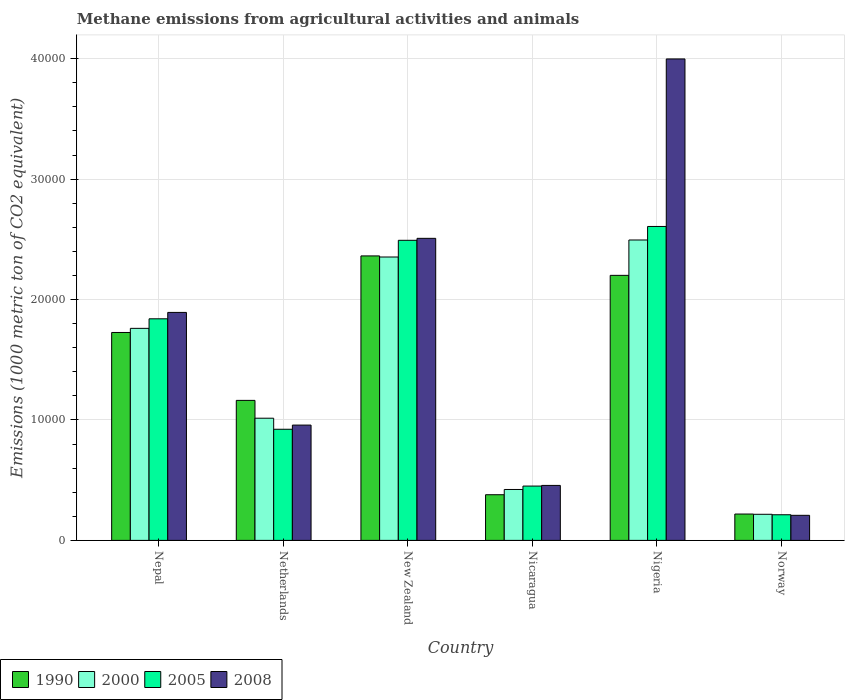How many different coloured bars are there?
Give a very brief answer. 4. Are the number of bars on each tick of the X-axis equal?
Keep it short and to the point. Yes. How many bars are there on the 2nd tick from the right?
Offer a terse response. 4. What is the label of the 5th group of bars from the left?
Your answer should be very brief. Nigeria. In how many cases, is the number of bars for a given country not equal to the number of legend labels?
Ensure brevity in your answer.  0. What is the amount of methane emitted in 2000 in Nigeria?
Your response must be concise. 2.49e+04. Across all countries, what is the maximum amount of methane emitted in 2000?
Provide a succinct answer. 2.49e+04. Across all countries, what is the minimum amount of methane emitted in 2008?
Your response must be concise. 2081.3. In which country was the amount of methane emitted in 2008 maximum?
Provide a short and direct response. Nigeria. What is the total amount of methane emitted in 2005 in the graph?
Your response must be concise. 8.53e+04. What is the difference between the amount of methane emitted in 1990 in Nepal and that in Norway?
Ensure brevity in your answer.  1.51e+04. What is the difference between the amount of methane emitted in 2000 in Nicaragua and the amount of methane emitted in 1990 in Nepal?
Your response must be concise. -1.30e+04. What is the average amount of methane emitted in 2000 per country?
Your answer should be compact. 1.38e+04. What is the difference between the amount of methane emitted of/in 2008 and amount of methane emitted of/in 2005 in Nepal?
Ensure brevity in your answer.  531.1. In how many countries, is the amount of methane emitted in 2008 greater than 32000 1000 metric ton?
Keep it short and to the point. 1. What is the ratio of the amount of methane emitted in 2000 in Nepal to that in Norway?
Your response must be concise. 8.12. What is the difference between the highest and the second highest amount of methane emitted in 2008?
Offer a very short reply. 1.49e+04. What is the difference between the highest and the lowest amount of methane emitted in 2008?
Keep it short and to the point. 3.79e+04. Is the sum of the amount of methane emitted in 1990 in New Zealand and Nicaragua greater than the maximum amount of methane emitted in 2005 across all countries?
Provide a succinct answer. Yes. Is it the case that in every country, the sum of the amount of methane emitted in 2008 and amount of methane emitted in 1990 is greater than the sum of amount of methane emitted in 2005 and amount of methane emitted in 2000?
Your answer should be compact. No. How many bars are there?
Provide a short and direct response. 24. Are all the bars in the graph horizontal?
Keep it short and to the point. No. How many countries are there in the graph?
Offer a terse response. 6. What is the difference between two consecutive major ticks on the Y-axis?
Make the answer very short. 10000. Does the graph contain any zero values?
Make the answer very short. No. Does the graph contain grids?
Keep it short and to the point. Yes. Where does the legend appear in the graph?
Keep it short and to the point. Bottom left. How many legend labels are there?
Provide a succinct answer. 4. How are the legend labels stacked?
Keep it short and to the point. Horizontal. What is the title of the graph?
Provide a short and direct response. Methane emissions from agricultural activities and animals. What is the label or title of the X-axis?
Your answer should be very brief. Country. What is the label or title of the Y-axis?
Offer a terse response. Emissions (1000 metric ton of CO2 equivalent). What is the Emissions (1000 metric ton of CO2 equivalent) in 1990 in Nepal?
Provide a succinct answer. 1.73e+04. What is the Emissions (1000 metric ton of CO2 equivalent) of 2000 in Nepal?
Offer a very short reply. 1.76e+04. What is the Emissions (1000 metric ton of CO2 equivalent) in 2005 in Nepal?
Your answer should be very brief. 1.84e+04. What is the Emissions (1000 metric ton of CO2 equivalent) in 2008 in Nepal?
Offer a very short reply. 1.89e+04. What is the Emissions (1000 metric ton of CO2 equivalent) of 1990 in Netherlands?
Ensure brevity in your answer.  1.16e+04. What is the Emissions (1000 metric ton of CO2 equivalent) of 2000 in Netherlands?
Give a very brief answer. 1.01e+04. What is the Emissions (1000 metric ton of CO2 equivalent) of 2005 in Netherlands?
Your answer should be very brief. 9228. What is the Emissions (1000 metric ton of CO2 equivalent) of 2008 in Netherlands?
Your answer should be very brief. 9574.5. What is the Emissions (1000 metric ton of CO2 equivalent) of 1990 in New Zealand?
Give a very brief answer. 2.36e+04. What is the Emissions (1000 metric ton of CO2 equivalent) in 2000 in New Zealand?
Offer a very short reply. 2.35e+04. What is the Emissions (1000 metric ton of CO2 equivalent) in 2005 in New Zealand?
Your answer should be very brief. 2.49e+04. What is the Emissions (1000 metric ton of CO2 equivalent) in 2008 in New Zealand?
Ensure brevity in your answer.  2.51e+04. What is the Emissions (1000 metric ton of CO2 equivalent) of 1990 in Nicaragua?
Provide a succinct answer. 3791.8. What is the Emissions (1000 metric ton of CO2 equivalent) of 2000 in Nicaragua?
Your answer should be very brief. 4227.1. What is the Emissions (1000 metric ton of CO2 equivalent) of 2005 in Nicaragua?
Your answer should be very brief. 4510. What is the Emissions (1000 metric ton of CO2 equivalent) of 2008 in Nicaragua?
Offer a very short reply. 4565.5. What is the Emissions (1000 metric ton of CO2 equivalent) of 1990 in Nigeria?
Your response must be concise. 2.20e+04. What is the Emissions (1000 metric ton of CO2 equivalent) in 2000 in Nigeria?
Offer a terse response. 2.49e+04. What is the Emissions (1000 metric ton of CO2 equivalent) in 2005 in Nigeria?
Your answer should be compact. 2.61e+04. What is the Emissions (1000 metric ton of CO2 equivalent) of 2008 in Nigeria?
Keep it short and to the point. 4.00e+04. What is the Emissions (1000 metric ton of CO2 equivalent) of 1990 in Norway?
Your answer should be compact. 2188.5. What is the Emissions (1000 metric ton of CO2 equivalent) of 2000 in Norway?
Ensure brevity in your answer.  2167.9. What is the Emissions (1000 metric ton of CO2 equivalent) in 2005 in Norway?
Keep it short and to the point. 2128.6. What is the Emissions (1000 metric ton of CO2 equivalent) of 2008 in Norway?
Make the answer very short. 2081.3. Across all countries, what is the maximum Emissions (1000 metric ton of CO2 equivalent) of 1990?
Offer a very short reply. 2.36e+04. Across all countries, what is the maximum Emissions (1000 metric ton of CO2 equivalent) in 2000?
Provide a succinct answer. 2.49e+04. Across all countries, what is the maximum Emissions (1000 metric ton of CO2 equivalent) in 2005?
Your response must be concise. 2.61e+04. Across all countries, what is the maximum Emissions (1000 metric ton of CO2 equivalent) in 2008?
Make the answer very short. 4.00e+04. Across all countries, what is the minimum Emissions (1000 metric ton of CO2 equivalent) in 1990?
Keep it short and to the point. 2188.5. Across all countries, what is the minimum Emissions (1000 metric ton of CO2 equivalent) in 2000?
Offer a very short reply. 2167.9. Across all countries, what is the minimum Emissions (1000 metric ton of CO2 equivalent) of 2005?
Your answer should be very brief. 2128.6. Across all countries, what is the minimum Emissions (1000 metric ton of CO2 equivalent) in 2008?
Provide a short and direct response. 2081.3. What is the total Emissions (1000 metric ton of CO2 equivalent) of 1990 in the graph?
Give a very brief answer. 8.05e+04. What is the total Emissions (1000 metric ton of CO2 equivalent) of 2000 in the graph?
Your answer should be compact. 8.26e+04. What is the total Emissions (1000 metric ton of CO2 equivalent) in 2005 in the graph?
Provide a succinct answer. 8.53e+04. What is the total Emissions (1000 metric ton of CO2 equivalent) in 2008 in the graph?
Your answer should be compact. 1.00e+05. What is the difference between the Emissions (1000 metric ton of CO2 equivalent) of 1990 in Nepal and that in Netherlands?
Your response must be concise. 5638.2. What is the difference between the Emissions (1000 metric ton of CO2 equivalent) in 2000 in Nepal and that in Netherlands?
Your answer should be compact. 7461.2. What is the difference between the Emissions (1000 metric ton of CO2 equivalent) of 2005 in Nepal and that in Netherlands?
Make the answer very short. 9171.3. What is the difference between the Emissions (1000 metric ton of CO2 equivalent) of 2008 in Nepal and that in Netherlands?
Offer a terse response. 9355.9. What is the difference between the Emissions (1000 metric ton of CO2 equivalent) of 1990 in Nepal and that in New Zealand?
Offer a terse response. -6357.4. What is the difference between the Emissions (1000 metric ton of CO2 equivalent) of 2000 in Nepal and that in New Zealand?
Offer a very short reply. -5924.7. What is the difference between the Emissions (1000 metric ton of CO2 equivalent) in 2005 in Nepal and that in New Zealand?
Provide a short and direct response. -6518.3. What is the difference between the Emissions (1000 metric ton of CO2 equivalent) in 2008 in Nepal and that in New Zealand?
Your answer should be very brief. -6150.8. What is the difference between the Emissions (1000 metric ton of CO2 equivalent) in 1990 in Nepal and that in Nicaragua?
Your answer should be compact. 1.35e+04. What is the difference between the Emissions (1000 metric ton of CO2 equivalent) in 2000 in Nepal and that in Nicaragua?
Give a very brief answer. 1.34e+04. What is the difference between the Emissions (1000 metric ton of CO2 equivalent) of 2005 in Nepal and that in Nicaragua?
Provide a short and direct response. 1.39e+04. What is the difference between the Emissions (1000 metric ton of CO2 equivalent) in 2008 in Nepal and that in Nicaragua?
Keep it short and to the point. 1.44e+04. What is the difference between the Emissions (1000 metric ton of CO2 equivalent) of 1990 in Nepal and that in Nigeria?
Your answer should be very brief. -4743.2. What is the difference between the Emissions (1000 metric ton of CO2 equivalent) of 2000 in Nepal and that in Nigeria?
Provide a short and direct response. -7337. What is the difference between the Emissions (1000 metric ton of CO2 equivalent) in 2005 in Nepal and that in Nigeria?
Your answer should be very brief. -7667.5. What is the difference between the Emissions (1000 metric ton of CO2 equivalent) of 2008 in Nepal and that in Nigeria?
Offer a terse response. -2.10e+04. What is the difference between the Emissions (1000 metric ton of CO2 equivalent) in 1990 in Nepal and that in Norway?
Give a very brief answer. 1.51e+04. What is the difference between the Emissions (1000 metric ton of CO2 equivalent) of 2000 in Nepal and that in Norway?
Your answer should be very brief. 1.54e+04. What is the difference between the Emissions (1000 metric ton of CO2 equivalent) in 2005 in Nepal and that in Norway?
Provide a short and direct response. 1.63e+04. What is the difference between the Emissions (1000 metric ton of CO2 equivalent) in 2008 in Nepal and that in Norway?
Give a very brief answer. 1.68e+04. What is the difference between the Emissions (1000 metric ton of CO2 equivalent) in 1990 in Netherlands and that in New Zealand?
Give a very brief answer. -1.20e+04. What is the difference between the Emissions (1000 metric ton of CO2 equivalent) in 2000 in Netherlands and that in New Zealand?
Give a very brief answer. -1.34e+04. What is the difference between the Emissions (1000 metric ton of CO2 equivalent) of 2005 in Netherlands and that in New Zealand?
Give a very brief answer. -1.57e+04. What is the difference between the Emissions (1000 metric ton of CO2 equivalent) in 2008 in Netherlands and that in New Zealand?
Your answer should be very brief. -1.55e+04. What is the difference between the Emissions (1000 metric ton of CO2 equivalent) in 1990 in Netherlands and that in Nicaragua?
Offer a very short reply. 7834.2. What is the difference between the Emissions (1000 metric ton of CO2 equivalent) in 2000 in Netherlands and that in Nicaragua?
Ensure brevity in your answer.  5917.7. What is the difference between the Emissions (1000 metric ton of CO2 equivalent) of 2005 in Netherlands and that in Nicaragua?
Give a very brief answer. 4718. What is the difference between the Emissions (1000 metric ton of CO2 equivalent) in 2008 in Netherlands and that in Nicaragua?
Make the answer very short. 5009. What is the difference between the Emissions (1000 metric ton of CO2 equivalent) in 1990 in Netherlands and that in Nigeria?
Make the answer very short. -1.04e+04. What is the difference between the Emissions (1000 metric ton of CO2 equivalent) in 2000 in Netherlands and that in Nigeria?
Ensure brevity in your answer.  -1.48e+04. What is the difference between the Emissions (1000 metric ton of CO2 equivalent) in 2005 in Netherlands and that in Nigeria?
Your response must be concise. -1.68e+04. What is the difference between the Emissions (1000 metric ton of CO2 equivalent) in 2008 in Netherlands and that in Nigeria?
Give a very brief answer. -3.04e+04. What is the difference between the Emissions (1000 metric ton of CO2 equivalent) of 1990 in Netherlands and that in Norway?
Provide a succinct answer. 9437.5. What is the difference between the Emissions (1000 metric ton of CO2 equivalent) of 2000 in Netherlands and that in Norway?
Provide a succinct answer. 7976.9. What is the difference between the Emissions (1000 metric ton of CO2 equivalent) in 2005 in Netherlands and that in Norway?
Keep it short and to the point. 7099.4. What is the difference between the Emissions (1000 metric ton of CO2 equivalent) in 2008 in Netherlands and that in Norway?
Your response must be concise. 7493.2. What is the difference between the Emissions (1000 metric ton of CO2 equivalent) of 1990 in New Zealand and that in Nicaragua?
Your answer should be very brief. 1.98e+04. What is the difference between the Emissions (1000 metric ton of CO2 equivalent) in 2000 in New Zealand and that in Nicaragua?
Provide a short and direct response. 1.93e+04. What is the difference between the Emissions (1000 metric ton of CO2 equivalent) in 2005 in New Zealand and that in Nicaragua?
Make the answer very short. 2.04e+04. What is the difference between the Emissions (1000 metric ton of CO2 equivalent) of 2008 in New Zealand and that in Nicaragua?
Your response must be concise. 2.05e+04. What is the difference between the Emissions (1000 metric ton of CO2 equivalent) in 1990 in New Zealand and that in Nigeria?
Your answer should be compact. 1614.2. What is the difference between the Emissions (1000 metric ton of CO2 equivalent) in 2000 in New Zealand and that in Nigeria?
Your response must be concise. -1412.3. What is the difference between the Emissions (1000 metric ton of CO2 equivalent) of 2005 in New Zealand and that in Nigeria?
Keep it short and to the point. -1149.2. What is the difference between the Emissions (1000 metric ton of CO2 equivalent) in 2008 in New Zealand and that in Nigeria?
Make the answer very short. -1.49e+04. What is the difference between the Emissions (1000 metric ton of CO2 equivalent) of 1990 in New Zealand and that in Norway?
Your response must be concise. 2.14e+04. What is the difference between the Emissions (1000 metric ton of CO2 equivalent) of 2000 in New Zealand and that in Norway?
Give a very brief answer. 2.14e+04. What is the difference between the Emissions (1000 metric ton of CO2 equivalent) in 2005 in New Zealand and that in Norway?
Offer a very short reply. 2.28e+04. What is the difference between the Emissions (1000 metric ton of CO2 equivalent) of 2008 in New Zealand and that in Norway?
Make the answer very short. 2.30e+04. What is the difference between the Emissions (1000 metric ton of CO2 equivalent) of 1990 in Nicaragua and that in Nigeria?
Offer a very short reply. -1.82e+04. What is the difference between the Emissions (1000 metric ton of CO2 equivalent) of 2000 in Nicaragua and that in Nigeria?
Provide a short and direct response. -2.07e+04. What is the difference between the Emissions (1000 metric ton of CO2 equivalent) in 2005 in Nicaragua and that in Nigeria?
Give a very brief answer. -2.16e+04. What is the difference between the Emissions (1000 metric ton of CO2 equivalent) of 2008 in Nicaragua and that in Nigeria?
Keep it short and to the point. -3.54e+04. What is the difference between the Emissions (1000 metric ton of CO2 equivalent) in 1990 in Nicaragua and that in Norway?
Ensure brevity in your answer.  1603.3. What is the difference between the Emissions (1000 metric ton of CO2 equivalent) in 2000 in Nicaragua and that in Norway?
Your answer should be compact. 2059.2. What is the difference between the Emissions (1000 metric ton of CO2 equivalent) in 2005 in Nicaragua and that in Norway?
Make the answer very short. 2381.4. What is the difference between the Emissions (1000 metric ton of CO2 equivalent) of 2008 in Nicaragua and that in Norway?
Your answer should be very brief. 2484.2. What is the difference between the Emissions (1000 metric ton of CO2 equivalent) of 1990 in Nigeria and that in Norway?
Your answer should be compact. 1.98e+04. What is the difference between the Emissions (1000 metric ton of CO2 equivalent) in 2000 in Nigeria and that in Norway?
Your response must be concise. 2.28e+04. What is the difference between the Emissions (1000 metric ton of CO2 equivalent) of 2005 in Nigeria and that in Norway?
Your answer should be compact. 2.39e+04. What is the difference between the Emissions (1000 metric ton of CO2 equivalent) of 2008 in Nigeria and that in Norway?
Your answer should be compact. 3.79e+04. What is the difference between the Emissions (1000 metric ton of CO2 equivalent) in 1990 in Nepal and the Emissions (1000 metric ton of CO2 equivalent) in 2000 in Netherlands?
Offer a very short reply. 7119.4. What is the difference between the Emissions (1000 metric ton of CO2 equivalent) in 1990 in Nepal and the Emissions (1000 metric ton of CO2 equivalent) in 2005 in Netherlands?
Ensure brevity in your answer.  8036.2. What is the difference between the Emissions (1000 metric ton of CO2 equivalent) of 1990 in Nepal and the Emissions (1000 metric ton of CO2 equivalent) of 2008 in Netherlands?
Offer a terse response. 7689.7. What is the difference between the Emissions (1000 metric ton of CO2 equivalent) in 2000 in Nepal and the Emissions (1000 metric ton of CO2 equivalent) in 2005 in Netherlands?
Your answer should be compact. 8378. What is the difference between the Emissions (1000 metric ton of CO2 equivalent) of 2000 in Nepal and the Emissions (1000 metric ton of CO2 equivalent) of 2008 in Netherlands?
Ensure brevity in your answer.  8031.5. What is the difference between the Emissions (1000 metric ton of CO2 equivalent) in 2005 in Nepal and the Emissions (1000 metric ton of CO2 equivalent) in 2008 in Netherlands?
Provide a succinct answer. 8824.8. What is the difference between the Emissions (1000 metric ton of CO2 equivalent) of 1990 in Nepal and the Emissions (1000 metric ton of CO2 equivalent) of 2000 in New Zealand?
Provide a short and direct response. -6266.5. What is the difference between the Emissions (1000 metric ton of CO2 equivalent) in 1990 in Nepal and the Emissions (1000 metric ton of CO2 equivalent) in 2005 in New Zealand?
Your answer should be very brief. -7653.4. What is the difference between the Emissions (1000 metric ton of CO2 equivalent) of 1990 in Nepal and the Emissions (1000 metric ton of CO2 equivalent) of 2008 in New Zealand?
Ensure brevity in your answer.  -7817. What is the difference between the Emissions (1000 metric ton of CO2 equivalent) of 2000 in Nepal and the Emissions (1000 metric ton of CO2 equivalent) of 2005 in New Zealand?
Offer a very short reply. -7311.6. What is the difference between the Emissions (1000 metric ton of CO2 equivalent) in 2000 in Nepal and the Emissions (1000 metric ton of CO2 equivalent) in 2008 in New Zealand?
Make the answer very short. -7475.2. What is the difference between the Emissions (1000 metric ton of CO2 equivalent) in 2005 in Nepal and the Emissions (1000 metric ton of CO2 equivalent) in 2008 in New Zealand?
Provide a short and direct response. -6681.9. What is the difference between the Emissions (1000 metric ton of CO2 equivalent) in 1990 in Nepal and the Emissions (1000 metric ton of CO2 equivalent) in 2000 in Nicaragua?
Your answer should be very brief. 1.30e+04. What is the difference between the Emissions (1000 metric ton of CO2 equivalent) in 1990 in Nepal and the Emissions (1000 metric ton of CO2 equivalent) in 2005 in Nicaragua?
Give a very brief answer. 1.28e+04. What is the difference between the Emissions (1000 metric ton of CO2 equivalent) of 1990 in Nepal and the Emissions (1000 metric ton of CO2 equivalent) of 2008 in Nicaragua?
Offer a very short reply. 1.27e+04. What is the difference between the Emissions (1000 metric ton of CO2 equivalent) of 2000 in Nepal and the Emissions (1000 metric ton of CO2 equivalent) of 2005 in Nicaragua?
Ensure brevity in your answer.  1.31e+04. What is the difference between the Emissions (1000 metric ton of CO2 equivalent) in 2000 in Nepal and the Emissions (1000 metric ton of CO2 equivalent) in 2008 in Nicaragua?
Offer a very short reply. 1.30e+04. What is the difference between the Emissions (1000 metric ton of CO2 equivalent) of 2005 in Nepal and the Emissions (1000 metric ton of CO2 equivalent) of 2008 in Nicaragua?
Your answer should be compact. 1.38e+04. What is the difference between the Emissions (1000 metric ton of CO2 equivalent) in 1990 in Nepal and the Emissions (1000 metric ton of CO2 equivalent) in 2000 in Nigeria?
Your answer should be very brief. -7678.8. What is the difference between the Emissions (1000 metric ton of CO2 equivalent) in 1990 in Nepal and the Emissions (1000 metric ton of CO2 equivalent) in 2005 in Nigeria?
Provide a succinct answer. -8802.6. What is the difference between the Emissions (1000 metric ton of CO2 equivalent) in 1990 in Nepal and the Emissions (1000 metric ton of CO2 equivalent) in 2008 in Nigeria?
Your response must be concise. -2.27e+04. What is the difference between the Emissions (1000 metric ton of CO2 equivalent) of 2000 in Nepal and the Emissions (1000 metric ton of CO2 equivalent) of 2005 in Nigeria?
Offer a very short reply. -8460.8. What is the difference between the Emissions (1000 metric ton of CO2 equivalent) in 2000 in Nepal and the Emissions (1000 metric ton of CO2 equivalent) in 2008 in Nigeria?
Offer a very short reply. -2.24e+04. What is the difference between the Emissions (1000 metric ton of CO2 equivalent) of 2005 in Nepal and the Emissions (1000 metric ton of CO2 equivalent) of 2008 in Nigeria?
Your response must be concise. -2.16e+04. What is the difference between the Emissions (1000 metric ton of CO2 equivalent) in 1990 in Nepal and the Emissions (1000 metric ton of CO2 equivalent) in 2000 in Norway?
Your response must be concise. 1.51e+04. What is the difference between the Emissions (1000 metric ton of CO2 equivalent) in 1990 in Nepal and the Emissions (1000 metric ton of CO2 equivalent) in 2005 in Norway?
Offer a very short reply. 1.51e+04. What is the difference between the Emissions (1000 metric ton of CO2 equivalent) in 1990 in Nepal and the Emissions (1000 metric ton of CO2 equivalent) in 2008 in Norway?
Make the answer very short. 1.52e+04. What is the difference between the Emissions (1000 metric ton of CO2 equivalent) in 2000 in Nepal and the Emissions (1000 metric ton of CO2 equivalent) in 2005 in Norway?
Provide a succinct answer. 1.55e+04. What is the difference between the Emissions (1000 metric ton of CO2 equivalent) in 2000 in Nepal and the Emissions (1000 metric ton of CO2 equivalent) in 2008 in Norway?
Ensure brevity in your answer.  1.55e+04. What is the difference between the Emissions (1000 metric ton of CO2 equivalent) in 2005 in Nepal and the Emissions (1000 metric ton of CO2 equivalent) in 2008 in Norway?
Provide a short and direct response. 1.63e+04. What is the difference between the Emissions (1000 metric ton of CO2 equivalent) in 1990 in Netherlands and the Emissions (1000 metric ton of CO2 equivalent) in 2000 in New Zealand?
Give a very brief answer. -1.19e+04. What is the difference between the Emissions (1000 metric ton of CO2 equivalent) of 1990 in Netherlands and the Emissions (1000 metric ton of CO2 equivalent) of 2005 in New Zealand?
Offer a terse response. -1.33e+04. What is the difference between the Emissions (1000 metric ton of CO2 equivalent) in 1990 in Netherlands and the Emissions (1000 metric ton of CO2 equivalent) in 2008 in New Zealand?
Offer a very short reply. -1.35e+04. What is the difference between the Emissions (1000 metric ton of CO2 equivalent) of 2000 in Netherlands and the Emissions (1000 metric ton of CO2 equivalent) of 2005 in New Zealand?
Your response must be concise. -1.48e+04. What is the difference between the Emissions (1000 metric ton of CO2 equivalent) in 2000 in Netherlands and the Emissions (1000 metric ton of CO2 equivalent) in 2008 in New Zealand?
Your answer should be very brief. -1.49e+04. What is the difference between the Emissions (1000 metric ton of CO2 equivalent) of 2005 in Netherlands and the Emissions (1000 metric ton of CO2 equivalent) of 2008 in New Zealand?
Offer a very short reply. -1.59e+04. What is the difference between the Emissions (1000 metric ton of CO2 equivalent) of 1990 in Netherlands and the Emissions (1000 metric ton of CO2 equivalent) of 2000 in Nicaragua?
Your answer should be very brief. 7398.9. What is the difference between the Emissions (1000 metric ton of CO2 equivalent) of 1990 in Netherlands and the Emissions (1000 metric ton of CO2 equivalent) of 2005 in Nicaragua?
Your answer should be compact. 7116. What is the difference between the Emissions (1000 metric ton of CO2 equivalent) in 1990 in Netherlands and the Emissions (1000 metric ton of CO2 equivalent) in 2008 in Nicaragua?
Your answer should be compact. 7060.5. What is the difference between the Emissions (1000 metric ton of CO2 equivalent) in 2000 in Netherlands and the Emissions (1000 metric ton of CO2 equivalent) in 2005 in Nicaragua?
Your answer should be compact. 5634.8. What is the difference between the Emissions (1000 metric ton of CO2 equivalent) in 2000 in Netherlands and the Emissions (1000 metric ton of CO2 equivalent) in 2008 in Nicaragua?
Provide a succinct answer. 5579.3. What is the difference between the Emissions (1000 metric ton of CO2 equivalent) in 2005 in Netherlands and the Emissions (1000 metric ton of CO2 equivalent) in 2008 in Nicaragua?
Your answer should be compact. 4662.5. What is the difference between the Emissions (1000 metric ton of CO2 equivalent) of 1990 in Netherlands and the Emissions (1000 metric ton of CO2 equivalent) of 2000 in Nigeria?
Keep it short and to the point. -1.33e+04. What is the difference between the Emissions (1000 metric ton of CO2 equivalent) of 1990 in Netherlands and the Emissions (1000 metric ton of CO2 equivalent) of 2005 in Nigeria?
Ensure brevity in your answer.  -1.44e+04. What is the difference between the Emissions (1000 metric ton of CO2 equivalent) in 1990 in Netherlands and the Emissions (1000 metric ton of CO2 equivalent) in 2008 in Nigeria?
Your answer should be compact. -2.84e+04. What is the difference between the Emissions (1000 metric ton of CO2 equivalent) in 2000 in Netherlands and the Emissions (1000 metric ton of CO2 equivalent) in 2005 in Nigeria?
Offer a very short reply. -1.59e+04. What is the difference between the Emissions (1000 metric ton of CO2 equivalent) in 2000 in Netherlands and the Emissions (1000 metric ton of CO2 equivalent) in 2008 in Nigeria?
Offer a terse response. -2.98e+04. What is the difference between the Emissions (1000 metric ton of CO2 equivalent) of 2005 in Netherlands and the Emissions (1000 metric ton of CO2 equivalent) of 2008 in Nigeria?
Provide a short and direct response. -3.07e+04. What is the difference between the Emissions (1000 metric ton of CO2 equivalent) in 1990 in Netherlands and the Emissions (1000 metric ton of CO2 equivalent) in 2000 in Norway?
Keep it short and to the point. 9458.1. What is the difference between the Emissions (1000 metric ton of CO2 equivalent) of 1990 in Netherlands and the Emissions (1000 metric ton of CO2 equivalent) of 2005 in Norway?
Ensure brevity in your answer.  9497.4. What is the difference between the Emissions (1000 metric ton of CO2 equivalent) in 1990 in Netherlands and the Emissions (1000 metric ton of CO2 equivalent) in 2008 in Norway?
Give a very brief answer. 9544.7. What is the difference between the Emissions (1000 metric ton of CO2 equivalent) in 2000 in Netherlands and the Emissions (1000 metric ton of CO2 equivalent) in 2005 in Norway?
Offer a very short reply. 8016.2. What is the difference between the Emissions (1000 metric ton of CO2 equivalent) of 2000 in Netherlands and the Emissions (1000 metric ton of CO2 equivalent) of 2008 in Norway?
Provide a succinct answer. 8063.5. What is the difference between the Emissions (1000 metric ton of CO2 equivalent) of 2005 in Netherlands and the Emissions (1000 metric ton of CO2 equivalent) of 2008 in Norway?
Give a very brief answer. 7146.7. What is the difference between the Emissions (1000 metric ton of CO2 equivalent) in 1990 in New Zealand and the Emissions (1000 metric ton of CO2 equivalent) in 2000 in Nicaragua?
Your answer should be very brief. 1.94e+04. What is the difference between the Emissions (1000 metric ton of CO2 equivalent) in 1990 in New Zealand and the Emissions (1000 metric ton of CO2 equivalent) in 2005 in Nicaragua?
Give a very brief answer. 1.91e+04. What is the difference between the Emissions (1000 metric ton of CO2 equivalent) of 1990 in New Zealand and the Emissions (1000 metric ton of CO2 equivalent) of 2008 in Nicaragua?
Your answer should be compact. 1.91e+04. What is the difference between the Emissions (1000 metric ton of CO2 equivalent) in 2000 in New Zealand and the Emissions (1000 metric ton of CO2 equivalent) in 2005 in Nicaragua?
Your response must be concise. 1.90e+04. What is the difference between the Emissions (1000 metric ton of CO2 equivalent) in 2000 in New Zealand and the Emissions (1000 metric ton of CO2 equivalent) in 2008 in Nicaragua?
Your answer should be compact. 1.90e+04. What is the difference between the Emissions (1000 metric ton of CO2 equivalent) of 2005 in New Zealand and the Emissions (1000 metric ton of CO2 equivalent) of 2008 in Nicaragua?
Provide a succinct answer. 2.04e+04. What is the difference between the Emissions (1000 metric ton of CO2 equivalent) of 1990 in New Zealand and the Emissions (1000 metric ton of CO2 equivalent) of 2000 in Nigeria?
Offer a terse response. -1321.4. What is the difference between the Emissions (1000 metric ton of CO2 equivalent) in 1990 in New Zealand and the Emissions (1000 metric ton of CO2 equivalent) in 2005 in Nigeria?
Offer a terse response. -2445.2. What is the difference between the Emissions (1000 metric ton of CO2 equivalent) in 1990 in New Zealand and the Emissions (1000 metric ton of CO2 equivalent) in 2008 in Nigeria?
Offer a very short reply. -1.64e+04. What is the difference between the Emissions (1000 metric ton of CO2 equivalent) in 2000 in New Zealand and the Emissions (1000 metric ton of CO2 equivalent) in 2005 in Nigeria?
Make the answer very short. -2536.1. What is the difference between the Emissions (1000 metric ton of CO2 equivalent) in 2000 in New Zealand and the Emissions (1000 metric ton of CO2 equivalent) in 2008 in Nigeria?
Your answer should be very brief. -1.64e+04. What is the difference between the Emissions (1000 metric ton of CO2 equivalent) in 2005 in New Zealand and the Emissions (1000 metric ton of CO2 equivalent) in 2008 in Nigeria?
Your answer should be compact. -1.51e+04. What is the difference between the Emissions (1000 metric ton of CO2 equivalent) in 1990 in New Zealand and the Emissions (1000 metric ton of CO2 equivalent) in 2000 in Norway?
Provide a short and direct response. 2.15e+04. What is the difference between the Emissions (1000 metric ton of CO2 equivalent) of 1990 in New Zealand and the Emissions (1000 metric ton of CO2 equivalent) of 2005 in Norway?
Ensure brevity in your answer.  2.15e+04. What is the difference between the Emissions (1000 metric ton of CO2 equivalent) of 1990 in New Zealand and the Emissions (1000 metric ton of CO2 equivalent) of 2008 in Norway?
Offer a very short reply. 2.15e+04. What is the difference between the Emissions (1000 metric ton of CO2 equivalent) of 2000 in New Zealand and the Emissions (1000 metric ton of CO2 equivalent) of 2005 in Norway?
Your answer should be very brief. 2.14e+04. What is the difference between the Emissions (1000 metric ton of CO2 equivalent) of 2000 in New Zealand and the Emissions (1000 metric ton of CO2 equivalent) of 2008 in Norway?
Ensure brevity in your answer.  2.14e+04. What is the difference between the Emissions (1000 metric ton of CO2 equivalent) of 2005 in New Zealand and the Emissions (1000 metric ton of CO2 equivalent) of 2008 in Norway?
Provide a short and direct response. 2.28e+04. What is the difference between the Emissions (1000 metric ton of CO2 equivalent) of 1990 in Nicaragua and the Emissions (1000 metric ton of CO2 equivalent) of 2000 in Nigeria?
Your answer should be very brief. -2.12e+04. What is the difference between the Emissions (1000 metric ton of CO2 equivalent) of 1990 in Nicaragua and the Emissions (1000 metric ton of CO2 equivalent) of 2005 in Nigeria?
Give a very brief answer. -2.23e+04. What is the difference between the Emissions (1000 metric ton of CO2 equivalent) of 1990 in Nicaragua and the Emissions (1000 metric ton of CO2 equivalent) of 2008 in Nigeria?
Offer a terse response. -3.62e+04. What is the difference between the Emissions (1000 metric ton of CO2 equivalent) in 2000 in Nicaragua and the Emissions (1000 metric ton of CO2 equivalent) in 2005 in Nigeria?
Provide a succinct answer. -2.18e+04. What is the difference between the Emissions (1000 metric ton of CO2 equivalent) in 2000 in Nicaragua and the Emissions (1000 metric ton of CO2 equivalent) in 2008 in Nigeria?
Your answer should be compact. -3.57e+04. What is the difference between the Emissions (1000 metric ton of CO2 equivalent) in 2005 in Nicaragua and the Emissions (1000 metric ton of CO2 equivalent) in 2008 in Nigeria?
Give a very brief answer. -3.55e+04. What is the difference between the Emissions (1000 metric ton of CO2 equivalent) of 1990 in Nicaragua and the Emissions (1000 metric ton of CO2 equivalent) of 2000 in Norway?
Your answer should be compact. 1623.9. What is the difference between the Emissions (1000 metric ton of CO2 equivalent) in 1990 in Nicaragua and the Emissions (1000 metric ton of CO2 equivalent) in 2005 in Norway?
Give a very brief answer. 1663.2. What is the difference between the Emissions (1000 metric ton of CO2 equivalent) of 1990 in Nicaragua and the Emissions (1000 metric ton of CO2 equivalent) of 2008 in Norway?
Provide a short and direct response. 1710.5. What is the difference between the Emissions (1000 metric ton of CO2 equivalent) of 2000 in Nicaragua and the Emissions (1000 metric ton of CO2 equivalent) of 2005 in Norway?
Provide a succinct answer. 2098.5. What is the difference between the Emissions (1000 metric ton of CO2 equivalent) in 2000 in Nicaragua and the Emissions (1000 metric ton of CO2 equivalent) in 2008 in Norway?
Your answer should be very brief. 2145.8. What is the difference between the Emissions (1000 metric ton of CO2 equivalent) in 2005 in Nicaragua and the Emissions (1000 metric ton of CO2 equivalent) in 2008 in Norway?
Your answer should be very brief. 2428.7. What is the difference between the Emissions (1000 metric ton of CO2 equivalent) in 1990 in Nigeria and the Emissions (1000 metric ton of CO2 equivalent) in 2000 in Norway?
Make the answer very short. 1.98e+04. What is the difference between the Emissions (1000 metric ton of CO2 equivalent) of 1990 in Nigeria and the Emissions (1000 metric ton of CO2 equivalent) of 2005 in Norway?
Your answer should be very brief. 1.99e+04. What is the difference between the Emissions (1000 metric ton of CO2 equivalent) in 1990 in Nigeria and the Emissions (1000 metric ton of CO2 equivalent) in 2008 in Norway?
Ensure brevity in your answer.  1.99e+04. What is the difference between the Emissions (1000 metric ton of CO2 equivalent) in 2000 in Nigeria and the Emissions (1000 metric ton of CO2 equivalent) in 2005 in Norway?
Provide a short and direct response. 2.28e+04. What is the difference between the Emissions (1000 metric ton of CO2 equivalent) of 2000 in Nigeria and the Emissions (1000 metric ton of CO2 equivalent) of 2008 in Norway?
Offer a terse response. 2.29e+04. What is the difference between the Emissions (1000 metric ton of CO2 equivalent) of 2005 in Nigeria and the Emissions (1000 metric ton of CO2 equivalent) of 2008 in Norway?
Offer a very short reply. 2.40e+04. What is the average Emissions (1000 metric ton of CO2 equivalent) of 1990 per country?
Give a very brief answer. 1.34e+04. What is the average Emissions (1000 metric ton of CO2 equivalent) in 2000 per country?
Provide a succinct answer. 1.38e+04. What is the average Emissions (1000 metric ton of CO2 equivalent) of 2005 per country?
Provide a short and direct response. 1.42e+04. What is the average Emissions (1000 metric ton of CO2 equivalent) of 2008 per country?
Your answer should be compact. 1.67e+04. What is the difference between the Emissions (1000 metric ton of CO2 equivalent) of 1990 and Emissions (1000 metric ton of CO2 equivalent) of 2000 in Nepal?
Offer a very short reply. -341.8. What is the difference between the Emissions (1000 metric ton of CO2 equivalent) in 1990 and Emissions (1000 metric ton of CO2 equivalent) in 2005 in Nepal?
Your answer should be compact. -1135.1. What is the difference between the Emissions (1000 metric ton of CO2 equivalent) of 1990 and Emissions (1000 metric ton of CO2 equivalent) of 2008 in Nepal?
Provide a succinct answer. -1666.2. What is the difference between the Emissions (1000 metric ton of CO2 equivalent) in 2000 and Emissions (1000 metric ton of CO2 equivalent) in 2005 in Nepal?
Offer a very short reply. -793.3. What is the difference between the Emissions (1000 metric ton of CO2 equivalent) of 2000 and Emissions (1000 metric ton of CO2 equivalent) of 2008 in Nepal?
Your answer should be very brief. -1324.4. What is the difference between the Emissions (1000 metric ton of CO2 equivalent) in 2005 and Emissions (1000 metric ton of CO2 equivalent) in 2008 in Nepal?
Offer a terse response. -531.1. What is the difference between the Emissions (1000 metric ton of CO2 equivalent) in 1990 and Emissions (1000 metric ton of CO2 equivalent) in 2000 in Netherlands?
Make the answer very short. 1481.2. What is the difference between the Emissions (1000 metric ton of CO2 equivalent) in 1990 and Emissions (1000 metric ton of CO2 equivalent) in 2005 in Netherlands?
Keep it short and to the point. 2398. What is the difference between the Emissions (1000 metric ton of CO2 equivalent) in 1990 and Emissions (1000 metric ton of CO2 equivalent) in 2008 in Netherlands?
Make the answer very short. 2051.5. What is the difference between the Emissions (1000 metric ton of CO2 equivalent) in 2000 and Emissions (1000 metric ton of CO2 equivalent) in 2005 in Netherlands?
Give a very brief answer. 916.8. What is the difference between the Emissions (1000 metric ton of CO2 equivalent) in 2000 and Emissions (1000 metric ton of CO2 equivalent) in 2008 in Netherlands?
Provide a succinct answer. 570.3. What is the difference between the Emissions (1000 metric ton of CO2 equivalent) of 2005 and Emissions (1000 metric ton of CO2 equivalent) of 2008 in Netherlands?
Offer a very short reply. -346.5. What is the difference between the Emissions (1000 metric ton of CO2 equivalent) of 1990 and Emissions (1000 metric ton of CO2 equivalent) of 2000 in New Zealand?
Give a very brief answer. 90.9. What is the difference between the Emissions (1000 metric ton of CO2 equivalent) in 1990 and Emissions (1000 metric ton of CO2 equivalent) in 2005 in New Zealand?
Your answer should be very brief. -1296. What is the difference between the Emissions (1000 metric ton of CO2 equivalent) in 1990 and Emissions (1000 metric ton of CO2 equivalent) in 2008 in New Zealand?
Ensure brevity in your answer.  -1459.6. What is the difference between the Emissions (1000 metric ton of CO2 equivalent) in 2000 and Emissions (1000 metric ton of CO2 equivalent) in 2005 in New Zealand?
Ensure brevity in your answer.  -1386.9. What is the difference between the Emissions (1000 metric ton of CO2 equivalent) of 2000 and Emissions (1000 metric ton of CO2 equivalent) of 2008 in New Zealand?
Offer a very short reply. -1550.5. What is the difference between the Emissions (1000 metric ton of CO2 equivalent) of 2005 and Emissions (1000 metric ton of CO2 equivalent) of 2008 in New Zealand?
Your answer should be compact. -163.6. What is the difference between the Emissions (1000 metric ton of CO2 equivalent) of 1990 and Emissions (1000 metric ton of CO2 equivalent) of 2000 in Nicaragua?
Your response must be concise. -435.3. What is the difference between the Emissions (1000 metric ton of CO2 equivalent) of 1990 and Emissions (1000 metric ton of CO2 equivalent) of 2005 in Nicaragua?
Your answer should be very brief. -718.2. What is the difference between the Emissions (1000 metric ton of CO2 equivalent) of 1990 and Emissions (1000 metric ton of CO2 equivalent) of 2008 in Nicaragua?
Your answer should be compact. -773.7. What is the difference between the Emissions (1000 metric ton of CO2 equivalent) in 2000 and Emissions (1000 metric ton of CO2 equivalent) in 2005 in Nicaragua?
Give a very brief answer. -282.9. What is the difference between the Emissions (1000 metric ton of CO2 equivalent) of 2000 and Emissions (1000 metric ton of CO2 equivalent) of 2008 in Nicaragua?
Your answer should be compact. -338.4. What is the difference between the Emissions (1000 metric ton of CO2 equivalent) of 2005 and Emissions (1000 metric ton of CO2 equivalent) of 2008 in Nicaragua?
Offer a very short reply. -55.5. What is the difference between the Emissions (1000 metric ton of CO2 equivalent) in 1990 and Emissions (1000 metric ton of CO2 equivalent) in 2000 in Nigeria?
Your response must be concise. -2935.6. What is the difference between the Emissions (1000 metric ton of CO2 equivalent) in 1990 and Emissions (1000 metric ton of CO2 equivalent) in 2005 in Nigeria?
Your response must be concise. -4059.4. What is the difference between the Emissions (1000 metric ton of CO2 equivalent) in 1990 and Emissions (1000 metric ton of CO2 equivalent) in 2008 in Nigeria?
Offer a very short reply. -1.80e+04. What is the difference between the Emissions (1000 metric ton of CO2 equivalent) in 2000 and Emissions (1000 metric ton of CO2 equivalent) in 2005 in Nigeria?
Provide a succinct answer. -1123.8. What is the difference between the Emissions (1000 metric ton of CO2 equivalent) of 2000 and Emissions (1000 metric ton of CO2 equivalent) of 2008 in Nigeria?
Ensure brevity in your answer.  -1.50e+04. What is the difference between the Emissions (1000 metric ton of CO2 equivalent) of 2005 and Emissions (1000 metric ton of CO2 equivalent) of 2008 in Nigeria?
Your response must be concise. -1.39e+04. What is the difference between the Emissions (1000 metric ton of CO2 equivalent) in 1990 and Emissions (1000 metric ton of CO2 equivalent) in 2000 in Norway?
Provide a succinct answer. 20.6. What is the difference between the Emissions (1000 metric ton of CO2 equivalent) of 1990 and Emissions (1000 metric ton of CO2 equivalent) of 2005 in Norway?
Give a very brief answer. 59.9. What is the difference between the Emissions (1000 metric ton of CO2 equivalent) of 1990 and Emissions (1000 metric ton of CO2 equivalent) of 2008 in Norway?
Make the answer very short. 107.2. What is the difference between the Emissions (1000 metric ton of CO2 equivalent) of 2000 and Emissions (1000 metric ton of CO2 equivalent) of 2005 in Norway?
Your response must be concise. 39.3. What is the difference between the Emissions (1000 metric ton of CO2 equivalent) of 2000 and Emissions (1000 metric ton of CO2 equivalent) of 2008 in Norway?
Make the answer very short. 86.6. What is the difference between the Emissions (1000 metric ton of CO2 equivalent) in 2005 and Emissions (1000 metric ton of CO2 equivalent) in 2008 in Norway?
Make the answer very short. 47.3. What is the ratio of the Emissions (1000 metric ton of CO2 equivalent) of 1990 in Nepal to that in Netherlands?
Provide a short and direct response. 1.49. What is the ratio of the Emissions (1000 metric ton of CO2 equivalent) of 2000 in Nepal to that in Netherlands?
Keep it short and to the point. 1.74. What is the ratio of the Emissions (1000 metric ton of CO2 equivalent) in 2005 in Nepal to that in Netherlands?
Offer a very short reply. 1.99. What is the ratio of the Emissions (1000 metric ton of CO2 equivalent) in 2008 in Nepal to that in Netherlands?
Provide a short and direct response. 1.98. What is the ratio of the Emissions (1000 metric ton of CO2 equivalent) in 1990 in Nepal to that in New Zealand?
Give a very brief answer. 0.73. What is the ratio of the Emissions (1000 metric ton of CO2 equivalent) in 2000 in Nepal to that in New Zealand?
Your answer should be very brief. 0.75. What is the ratio of the Emissions (1000 metric ton of CO2 equivalent) in 2005 in Nepal to that in New Zealand?
Offer a very short reply. 0.74. What is the ratio of the Emissions (1000 metric ton of CO2 equivalent) in 2008 in Nepal to that in New Zealand?
Offer a terse response. 0.75. What is the ratio of the Emissions (1000 metric ton of CO2 equivalent) of 1990 in Nepal to that in Nicaragua?
Make the answer very short. 4.55. What is the ratio of the Emissions (1000 metric ton of CO2 equivalent) of 2000 in Nepal to that in Nicaragua?
Offer a terse response. 4.17. What is the ratio of the Emissions (1000 metric ton of CO2 equivalent) of 2005 in Nepal to that in Nicaragua?
Your response must be concise. 4.08. What is the ratio of the Emissions (1000 metric ton of CO2 equivalent) in 2008 in Nepal to that in Nicaragua?
Your answer should be very brief. 4.15. What is the ratio of the Emissions (1000 metric ton of CO2 equivalent) of 1990 in Nepal to that in Nigeria?
Your answer should be compact. 0.78. What is the ratio of the Emissions (1000 metric ton of CO2 equivalent) of 2000 in Nepal to that in Nigeria?
Your answer should be very brief. 0.71. What is the ratio of the Emissions (1000 metric ton of CO2 equivalent) in 2005 in Nepal to that in Nigeria?
Your response must be concise. 0.71. What is the ratio of the Emissions (1000 metric ton of CO2 equivalent) of 2008 in Nepal to that in Nigeria?
Your response must be concise. 0.47. What is the ratio of the Emissions (1000 metric ton of CO2 equivalent) of 1990 in Nepal to that in Norway?
Ensure brevity in your answer.  7.89. What is the ratio of the Emissions (1000 metric ton of CO2 equivalent) in 2000 in Nepal to that in Norway?
Provide a succinct answer. 8.12. What is the ratio of the Emissions (1000 metric ton of CO2 equivalent) of 2005 in Nepal to that in Norway?
Your answer should be very brief. 8.64. What is the ratio of the Emissions (1000 metric ton of CO2 equivalent) in 2008 in Nepal to that in Norway?
Your response must be concise. 9.1. What is the ratio of the Emissions (1000 metric ton of CO2 equivalent) of 1990 in Netherlands to that in New Zealand?
Ensure brevity in your answer.  0.49. What is the ratio of the Emissions (1000 metric ton of CO2 equivalent) in 2000 in Netherlands to that in New Zealand?
Ensure brevity in your answer.  0.43. What is the ratio of the Emissions (1000 metric ton of CO2 equivalent) in 2005 in Netherlands to that in New Zealand?
Your answer should be compact. 0.37. What is the ratio of the Emissions (1000 metric ton of CO2 equivalent) in 2008 in Netherlands to that in New Zealand?
Your answer should be compact. 0.38. What is the ratio of the Emissions (1000 metric ton of CO2 equivalent) in 1990 in Netherlands to that in Nicaragua?
Ensure brevity in your answer.  3.07. What is the ratio of the Emissions (1000 metric ton of CO2 equivalent) in 2000 in Netherlands to that in Nicaragua?
Make the answer very short. 2.4. What is the ratio of the Emissions (1000 metric ton of CO2 equivalent) of 2005 in Netherlands to that in Nicaragua?
Your answer should be compact. 2.05. What is the ratio of the Emissions (1000 metric ton of CO2 equivalent) in 2008 in Netherlands to that in Nicaragua?
Offer a very short reply. 2.1. What is the ratio of the Emissions (1000 metric ton of CO2 equivalent) of 1990 in Netherlands to that in Nigeria?
Provide a short and direct response. 0.53. What is the ratio of the Emissions (1000 metric ton of CO2 equivalent) in 2000 in Netherlands to that in Nigeria?
Offer a terse response. 0.41. What is the ratio of the Emissions (1000 metric ton of CO2 equivalent) in 2005 in Netherlands to that in Nigeria?
Provide a short and direct response. 0.35. What is the ratio of the Emissions (1000 metric ton of CO2 equivalent) in 2008 in Netherlands to that in Nigeria?
Offer a terse response. 0.24. What is the ratio of the Emissions (1000 metric ton of CO2 equivalent) of 1990 in Netherlands to that in Norway?
Ensure brevity in your answer.  5.31. What is the ratio of the Emissions (1000 metric ton of CO2 equivalent) in 2000 in Netherlands to that in Norway?
Provide a short and direct response. 4.68. What is the ratio of the Emissions (1000 metric ton of CO2 equivalent) of 2005 in Netherlands to that in Norway?
Provide a succinct answer. 4.34. What is the ratio of the Emissions (1000 metric ton of CO2 equivalent) of 2008 in Netherlands to that in Norway?
Your answer should be very brief. 4.6. What is the ratio of the Emissions (1000 metric ton of CO2 equivalent) in 1990 in New Zealand to that in Nicaragua?
Your answer should be very brief. 6.23. What is the ratio of the Emissions (1000 metric ton of CO2 equivalent) in 2000 in New Zealand to that in Nicaragua?
Offer a very short reply. 5.57. What is the ratio of the Emissions (1000 metric ton of CO2 equivalent) in 2005 in New Zealand to that in Nicaragua?
Offer a terse response. 5.53. What is the ratio of the Emissions (1000 metric ton of CO2 equivalent) in 2008 in New Zealand to that in Nicaragua?
Give a very brief answer. 5.49. What is the ratio of the Emissions (1000 metric ton of CO2 equivalent) of 1990 in New Zealand to that in Nigeria?
Your answer should be compact. 1.07. What is the ratio of the Emissions (1000 metric ton of CO2 equivalent) in 2000 in New Zealand to that in Nigeria?
Keep it short and to the point. 0.94. What is the ratio of the Emissions (1000 metric ton of CO2 equivalent) in 2005 in New Zealand to that in Nigeria?
Offer a very short reply. 0.96. What is the ratio of the Emissions (1000 metric ton of CO2 equivalent) in 2008 in New Zealand to that in Nigeria?
Ensure brevity in your answer.  0.63. What is the ratio of the Emissions (1000 metric ton of CO2 equivalent) of 1990 in New Zealand to that in Norway?
Make the answer very short. 10.79. What is the ratio of the Emissions (1000 metric ton of CO2 equivalent) in 2000 in New Zealand to that in Norway?
Keep it short and to the point. 10.85. What is the ratio of the Emissions (1000 metric ton of CO2 equivalent) of 2005 in New Zealand to that in Norway?
Your response must be concise. 11.71. What is the ratio of the Emissions (1000 metric ton of CO2 equivalent) in 2008 in New Zealand to that in Norway?
Make the answer very short. 12.05. What is the ratio of the Emissions (1000 metric ton of CO2 equivalent) of 1990 in Nicaragua to that in Nigeria?
Give a very brief answer. 0.17. What is the ratio of the Emissions (1000 metric ton of CO2 equivalent) of 2000 in Nicaragua to that in Nigeria?
Give a very brief answer. 0.17. What is the ratio of the Emissions (1000 metric ton of CO2 equivalent) in 2005 in Nicaragua to that in Nigeria?
Your response must be concise. 0.17. What is the ratio of the Emissions (1000 metric ton of CO2 equivalent) of 2008 in Nicaragua to that in Nigeria?
Your answer should be very brief. 0.11. What is the ratio of the Emissions (1000 metric ton of CO2 equivalent) in 1990 in Nicaragua to that in Norway?
Provide a succinct answer. 1.73. What is the ratio of the Emissions (1000 metric ton of CO2 equivalent) of 2000 in Nicaragua to that in Norway?
Offer a terse response. 1.95. What is the ratio of the Emissions (1000 metric ton of CO2 equivalent) of 2005 in Nicaragua to that in Norway?
Your response must be concise. 2.12. What is the ratio of the Emissions (1000 metric ton of CO2 equivalent) of 2008 in Nicaragua to that in Norway?
Offer a terse response. 2.19. What is the ratio of the Emissions (1000 metric ton of CO2 equivalent) in 1990 in Nigeria to that in Norway?
Your answer should be compact. 10.06. What is the ratio of the Emissions (1000 metric ton of CO2 equivalent) of 2000 in Nigeria to that in Norway?
Provide a short and direct response. 11.51. What is the ratio of the Emissions (1000 metric ton of CO2 equivalent) of 2005 in Nigeria to that in Norway?
Make the answer very short. 12.25. What is the ratio of the Emissions (1000 metric ton of CO2 equivalent) in 2008 in Nigeria to that in Norway?
Keep it short and to the point. 19.21. What is the difference between the highest and the second highest Emissions (1000 metric ton of CO2 equivalent) in 1990?
Give a very brief answer. 1614.2. What is the difference between the highest and the second highest Emissions (1000 metric ton of CO2 equivalent) of 2000?
Provide a succinct answer. 1412.3. What is the difference between the highest and the second highest Emissions (1000 metric ton of CO2 equivalent) in 2005?
Keep it short and to the point. 1149.2. What is the difference between the highest and the second highest Emissions (1000 metric ton of CO2 equivalent) in 2008?
Provide a short and direct response. 1.49e+04. What is the difference between the highest and the lowest Emissions (1000 metric ton of CO2 equivalent) of 1990?
Your answer should be very brief. 2.14e+04. What is the difference between the highest and the lowest Emissions (1000 metric ton of CO2 equivalent) in 2000?
Your answer should be compact. 2.28e+04. What is the difference between the highest and the lowest Emissions (1000 metric ton of CO2 equivalent) of 2005?
Offer a terse response. 2.39e+04. What is the difference between the highest and the lowest Emissions (1000 metric ton of CO2 equivalent) in 2008?
Provide a succinct answer. 3.79e+04. 